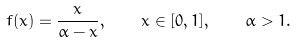<formula> <loc_0><loc_0><loc_500><loc_500>f ( x ) = \frac { x } { \alpha - x } , \quad x \in [ 0 , 1 ] , \quad \alpha > 1 .</formula> 